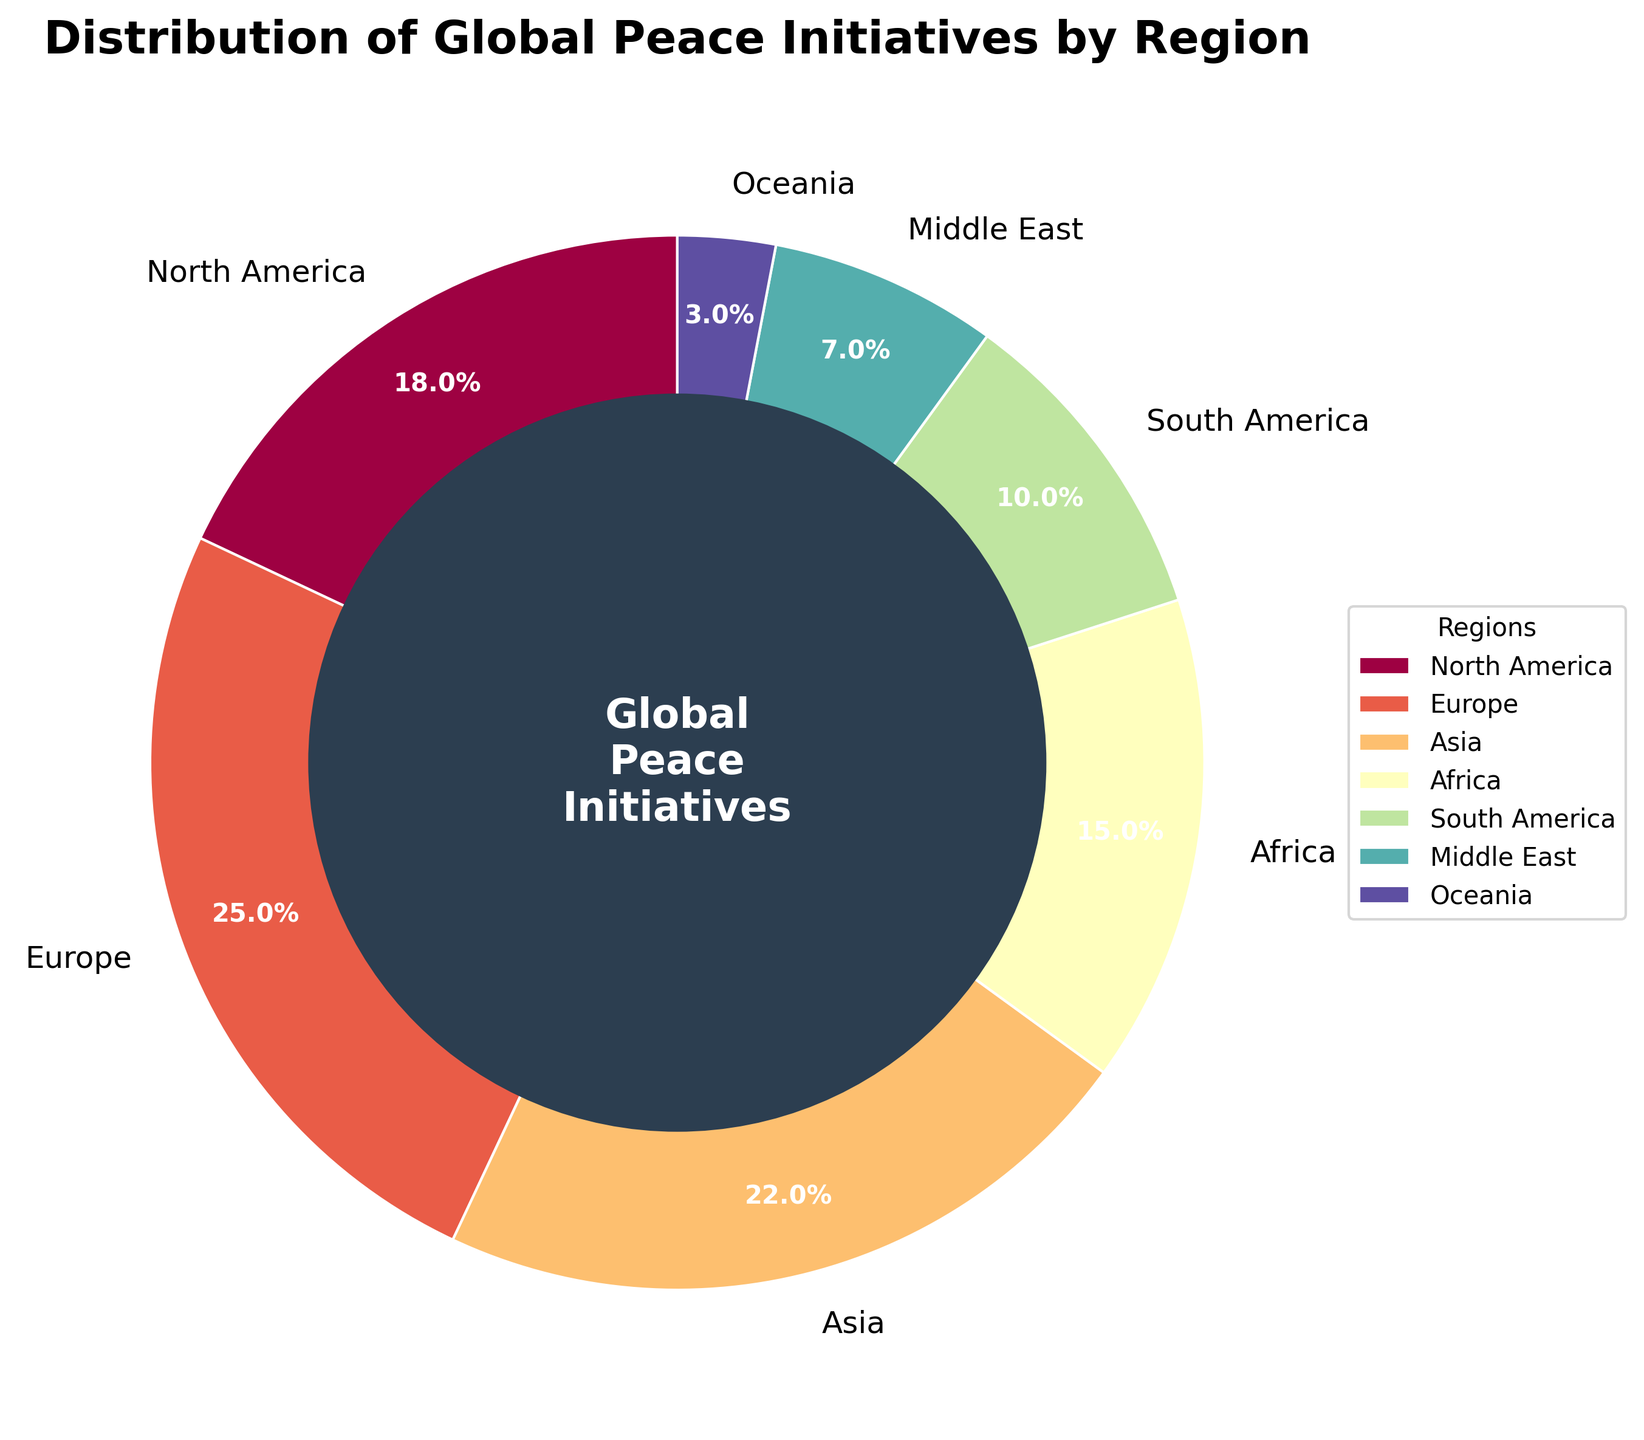What region has the highest percentage of global peace initiatives? The region with the highest percentage is the one where the pie slice has the largest area. From the figure, Europe has the largest area.
Answer: Europe What region has the lowest percentage of global peace initiatives? The region with the lowest percentage is the one where the pie slice has the smallest area. From the figure, Oceania has the smallest area.
Answer: Oceania How much more is the percentage of global peace initiatives in Asia compared to Africa? To find the difference, subtract Africa's percentage from Asia's percentage. Asia is 22% and Africa is 15%, so the difference is 22% - 15%.
Answer: 7% What is the combined percentage of global peace initiatives in North America and South America? Add the percentages of North America and South America. North America is 18% and South America is 10%, so their combined percentage is 18% + 10%.
Answer: 28% How does the percentage of global peace initiatives in the Middle East compare to that in Africa? Compare the percentages directly. The Middle East has 7% while Africa has 15%, so the Middle East has a lower percentage.
Answer: Lower What fraction of the global peace initiative pie is represented by Europe and Asia combined? Add their percentages and convert the total to a fraction. Europe is 25% and Asia is 22%, so their combined percentage is 25% + 22% = 47%. As a fraction of 100%, it is 47/100.
Answer: 47/100 Is the percentage of global peace initiatives in Europe greater than or equal to the combined percentage in Africa and South America? First find the combined percentage of Africa and South America, which is 15% + 10% = 25%. Compare with Europe, which is 25%. Since 25% is equal to 25%, they are equal.
Answer: Yes Rank the regions from highest to lowest in terms of the percentage of global peace initiatives. Order the regions by their percentages in descending order: Europe (25%), Asia (22%), North America (18%), Africa (15%), South America (10%), Middle East (7%), Oceania (3%).
Answer: Europe, Asia, North America, Africa, South America, Middle East, Oceania What is the percentage difference between the region with the highest percentage and the region with the lowest percentage of global peace initiatives? Subtract the percentage of the region with the lowest percentage (Oceania, 3%) from the percentage of the region with the highest percentage (Europe, 25%). The difference is 25% - 3%.
Answer: 22% What percentage of global peace initiatives are taken by regions other than North America, Europe, and Asia? Subtract the combined percentage of North America, Europe, and Asia from 100%. Their combined percentage is 18% + 25% + 22% = 65%. Subtracting from 100% gives 100% - 65%.
Answer: 35% 